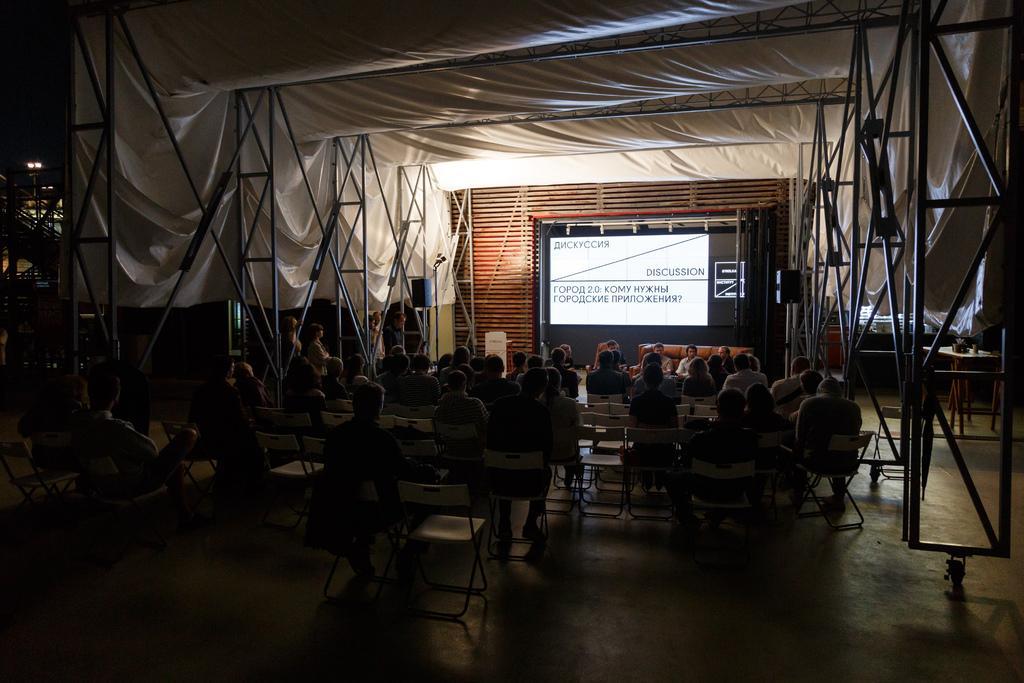Describe this image in one or two sentences. In this picture there are few people sitting on the chair. There is a screen. There is a sheet and light at the background. 